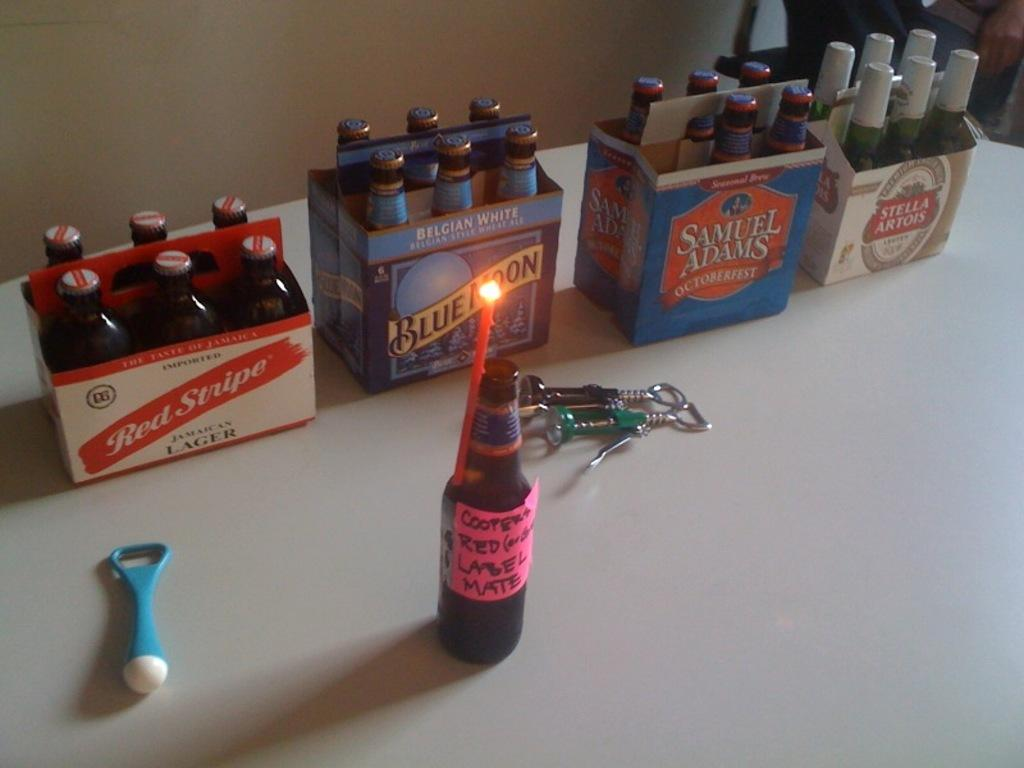<image>
Present a compact description of the photo's key features. several six packs of beer for brands like Red STripe and Blue moon 